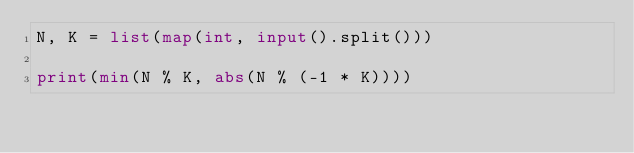<code> <loc_0><loc_0><loc_500><loc_500><_Python_>N, K = list(map(int, input().split()))

print(min(N % K, abs(N % (-1 * K))))
</code> 